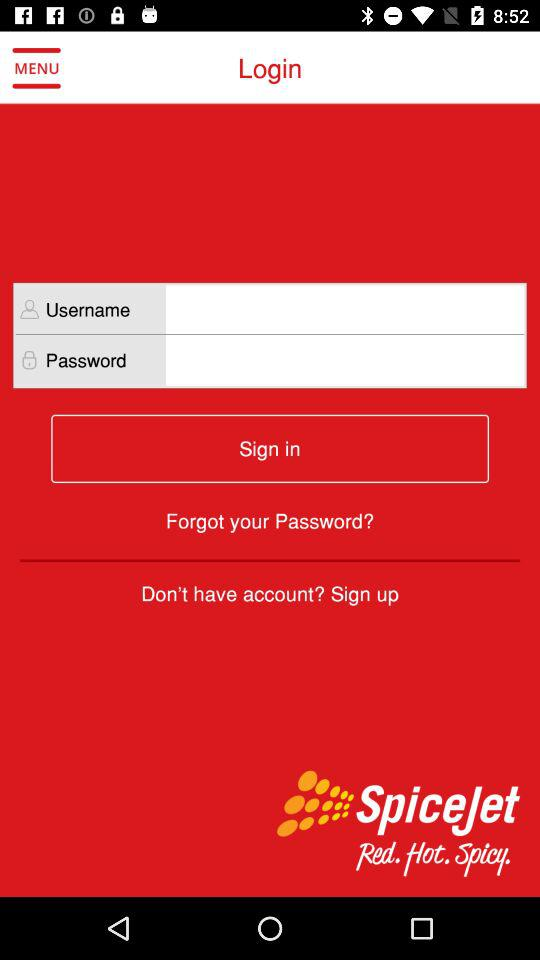What is the application name? The application name is "SpiceJet". 